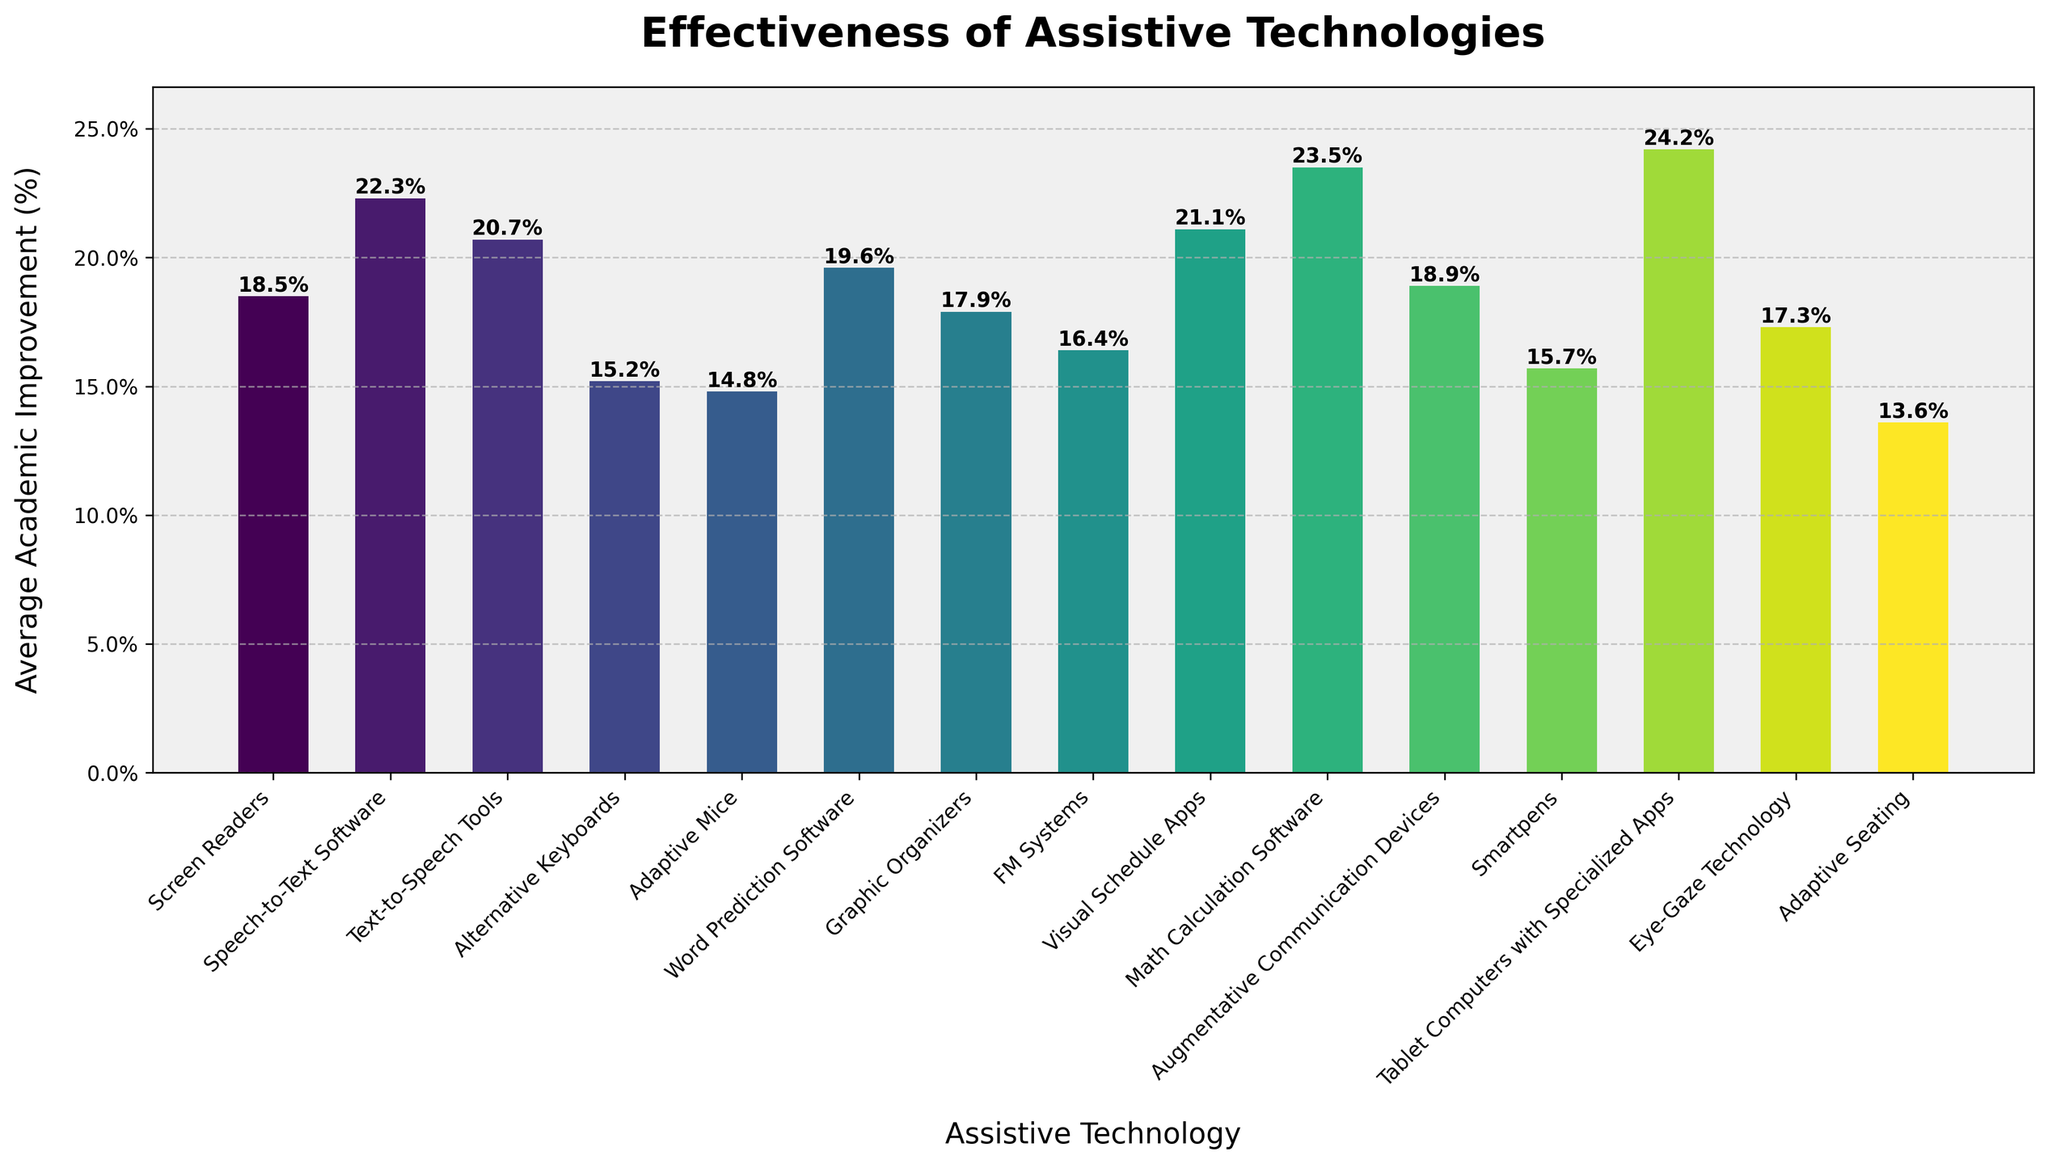What is the most effective assistive technology according to the bar chart? Look at the bar with the greatest height. "Tablet Computers with Specialized Apps" has the highest bar.
Answer: Tablet Computers with Specialized Apps Which assistive technology shows the least academic improvement? Look at the bar with the smallest height. "Adaptive Seating" has the shortest bar.
Answer: Adaptive Seating What is the average academic improvement (%) for Screen Readers and Speech-to-Text Software? Add the academic improvements of Screen Readers (18.5%) and Speech-to-Text Software (22.3%). Then, divide by 2. (18.5 + 22.3) / 2 = 20.4
Answer: 20.4 How much higher is the academic improvement for Math Calculation Software compared to Adaptive Mice? Subtract the academic improvement of Adaptive Mice (14.8%) from Math Calculation Software (23.5%). 23.5 - 14.8 = 8.7
Answer: 8.7 Is the academic improvement of Visual Schedule Apps greater than that of Alternative Keyboards and FM Systems combined? Add the academic improvement of Alternative Keyboards (15.2%) and FM Systems (16.4%). Compare this sum to Visual Schedule Apps (21.1%). 15.2 + 16.4 = 31.6, which is greater than 21.1.
Answer: No Which two assistive technologies have the closest academic improvement percentages? Look at the values and find the two closest numbers. "Smartpens (15.7%)" and "Adaptive Keyboards (15.2%)" are close together, with a difference of 0.5.
Answer: Smartpens and Alternative Keyboards What is the total academic improvement (%) for Word Prediction Software, Graphic Organizers, and FM Systems? Add the academic improvements of Word Prediction Software (19.6%), Graphic Organizers (17.9%), and FM Systems (16.4%). 19.6 + 17.9 + 16.4 = 53.9
Answer: 53.9 How many assistive technologies have an academic improvement greater than 20%? Count the bars exceeding 20% in height. Speech-to-Text Software (22.3%), Text-to-Speech Tools (20.7%), Visual Schedule Apps (21.1%), Math Calculation Software (23.5%), and Tablet Computers with Specialized Apps (24.2%) are above 20%. There are 5 such technologies.
Answer: 5 Which assistive technology with an improvement less than 19% has the highest academic improvement? Among those with improvements less than 19%, "Augmentative Communication Devices" has the highest value (18.9%).
Answer: Augmentative Communication Devices What is the difference in academic improvement between the highest and lowest performing technologies? Subtract the academic improvement of the lowest performing technology, Adaptive Seating (13.6%), from the highest, Tablet Computers with Specialized Apps (24.2%). 24.2 - 13.6 = 10.6
Answer: 10.6 